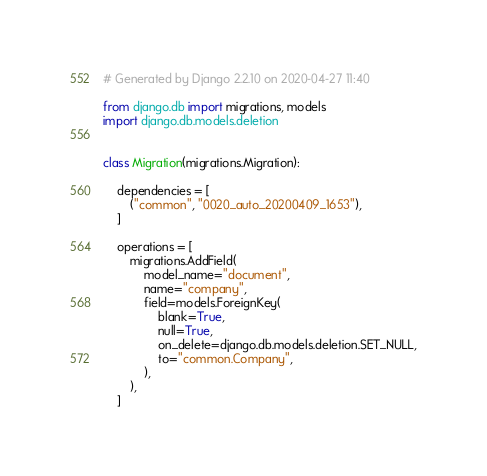Convert code to text. <code><loc_0><loc_0><loc_500><loc_500><_Python_># Generated by Django 2.2.10 on 2020-04-27 11:40

from django.db import migrations, models
import django.db.models.deletion


class Migration(migrations.Migration):

    dependencies = [
        ("common", "0020_auto_20200409_1653"),
    ]

    operations = [
        migrations.AddField(
            model_name="document",
            name="company",
            field=models.ForeignKey(
                blank=True,
                null=True,
                on_delete=django.db.models.deletion.SET_NULL,
                to="common.Company",
            ),
        ),
    ]
</code> 